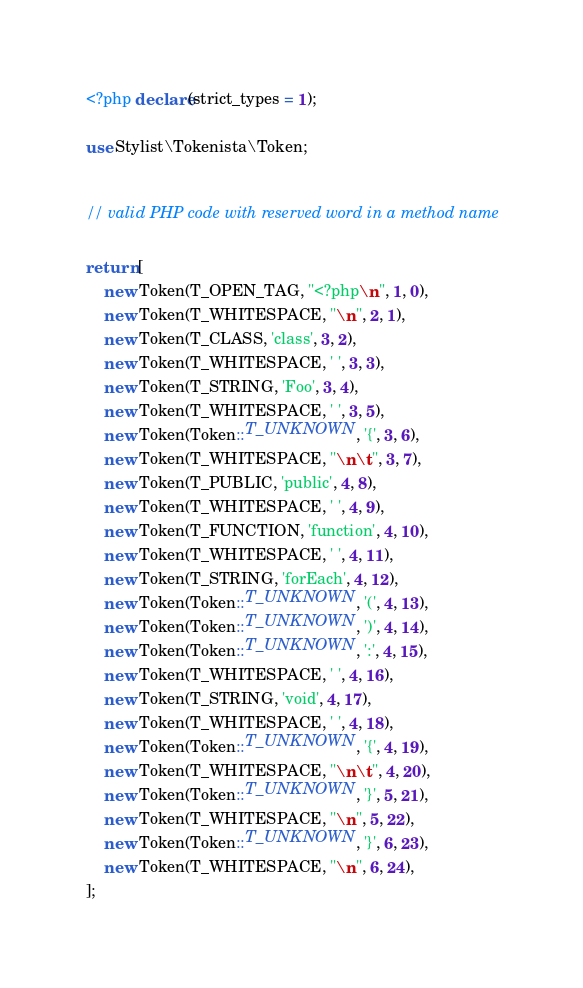Convert code to text. <code><loc_0><loc_0><loc_500><loc_500><_PHP_><?php declare(strict_types = 1);

use Stylist\Tokenista\Token;


// valid PHP code with reserved word in a method name

return [
	new Token(T_OPEN_TAG, "<?php\n", 1, 0),
	new Token(T_WHITESPACE, "\n", 2, 1),
	new Token(T_CLASS, 'class', 3, 2),
	new Token(T_WHITESPACE, ' ', 3, 3),
	new Token(T_STRING, 'Foo', 3, 4),
	new Token(T_WHITESPACE, ' ', 3, 5),
	new Token(Token::T_UNKNOWN, '{', 3, 6),
	new Token(T_WHITESPACE, "\n\t", 3, 7),
	new Token(T_PUBLIC, 'public', 4, 8),
	new Token(T_WHITESPACE, ' ', 4, 9),
	new Token(T_FUNCTION, 'function', 4, 10),
	new Token(T_WHITESPACE, ' ', 4, 11),
	new Token(T_STRING, 'forEach', 4, 12),
	new Token(Token::T_UNKNOWN, '(', 4, 13),
	new Token(Token::T_UNKNOWN, ')', 4, 14),
	new Token(Token::T_UNKNOWN, ':', 4, 15),
	new Token(T_WHITESPACE, ' ', 4, 16),
	new Token(T_STRING, 'void', 4, 17),
	new Token(T_WHITESPACE, ' ', 4, 18),
	new Token(Token::T_UNKNOWN, '{', 4, 19),
	new Token(T_WHITESPACE, "\n\t", 4, 20),
	new Token(Token::T_UNKNOWN, '}', 5, 21),
	new Token(T_WHITESPACE, "\n", 5, 22),
	new Token(Token::T_UNKNOWN, '}', 6, 23),
	new Token(T_WHITESPACE, "\n", 6, 24),
];
</code> 